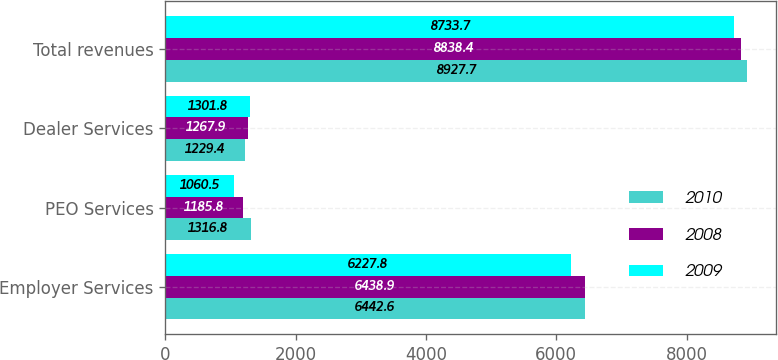Convert chart to OTSL. <chart><loc_0><loc_0><loc_500><loc_500><stacked_bar_chart><ecel><fcel>Employer Services<fcel>PEO Services<fcel>Dealer Services<fcel>Total revenues<nl><fcel>2010<fcel>6442.6<fcel>1316.8<fcel>1229.4<fcel>8927.7<nl><fcel>2008<fcel>6438.9<fcel>1185.8<fcel>1267.9<fcel>8838.4<nl><fcel>2009<fcel>6227.8<fcel>1060.5<fcel>1301.8<fcel>8733.7<nl></chart> 